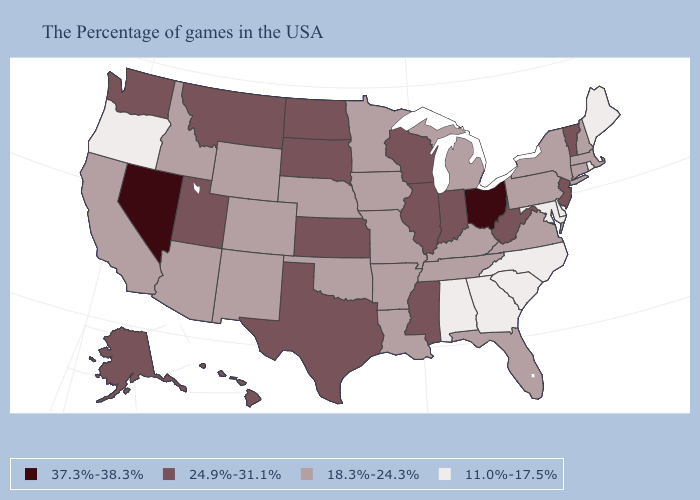Is the legend a continuous bar?
Be succinct. No. What is the highest value in the USA?
Keep it brief. 37.3%-38.3%. Which states have the lowest value in the Northeast?
Give a very brief answer. Maine, Rhode Island. Name the states that have a value in the range 11.0%-17.5%?
Concise answer only. Maine, Rhode Island, Delaware, Maryland, North Carolina, South Carolina, Georgia, Alabama, Oregon. How many symbols are there in the legend?
Answer briefly. 4. Among the states that border Indiana , which have the lowest value?
Short answer required. Michigan, Kentucky. How many symbols are there in the legend?
Be succinct. 4. Does Florida have the lowest value in the South?
Short answer required. No. Does the map have missing data?
Concise answer only. No. What is the value of Mississippi?
Concise answer only. 24.9%-31.1%. Name the states that have a value in the range 18.3%-24.3%?
Concise answer only. Massachusetts, New Hampshire, Connecticut, New York, Pennsylvania, Virginia, Florida, Michigan, Kentucky, Tennessee, Louisiana, Missouri, Arkansas, Minnesota, Iowa, Nebraska, Oklahoma, Wyoming, Colorado, New Mexico, Arizona, Idaho, California. What is the highest value in the MidWest ?
Write a very short answer. 37.3%-38.3%. What is the highest value in the USA?
Write a very short answer. 37.3%-38.3%. Which states hav the highest value in the Northeast?
Quick response, please. Vermont, New Jersey. 